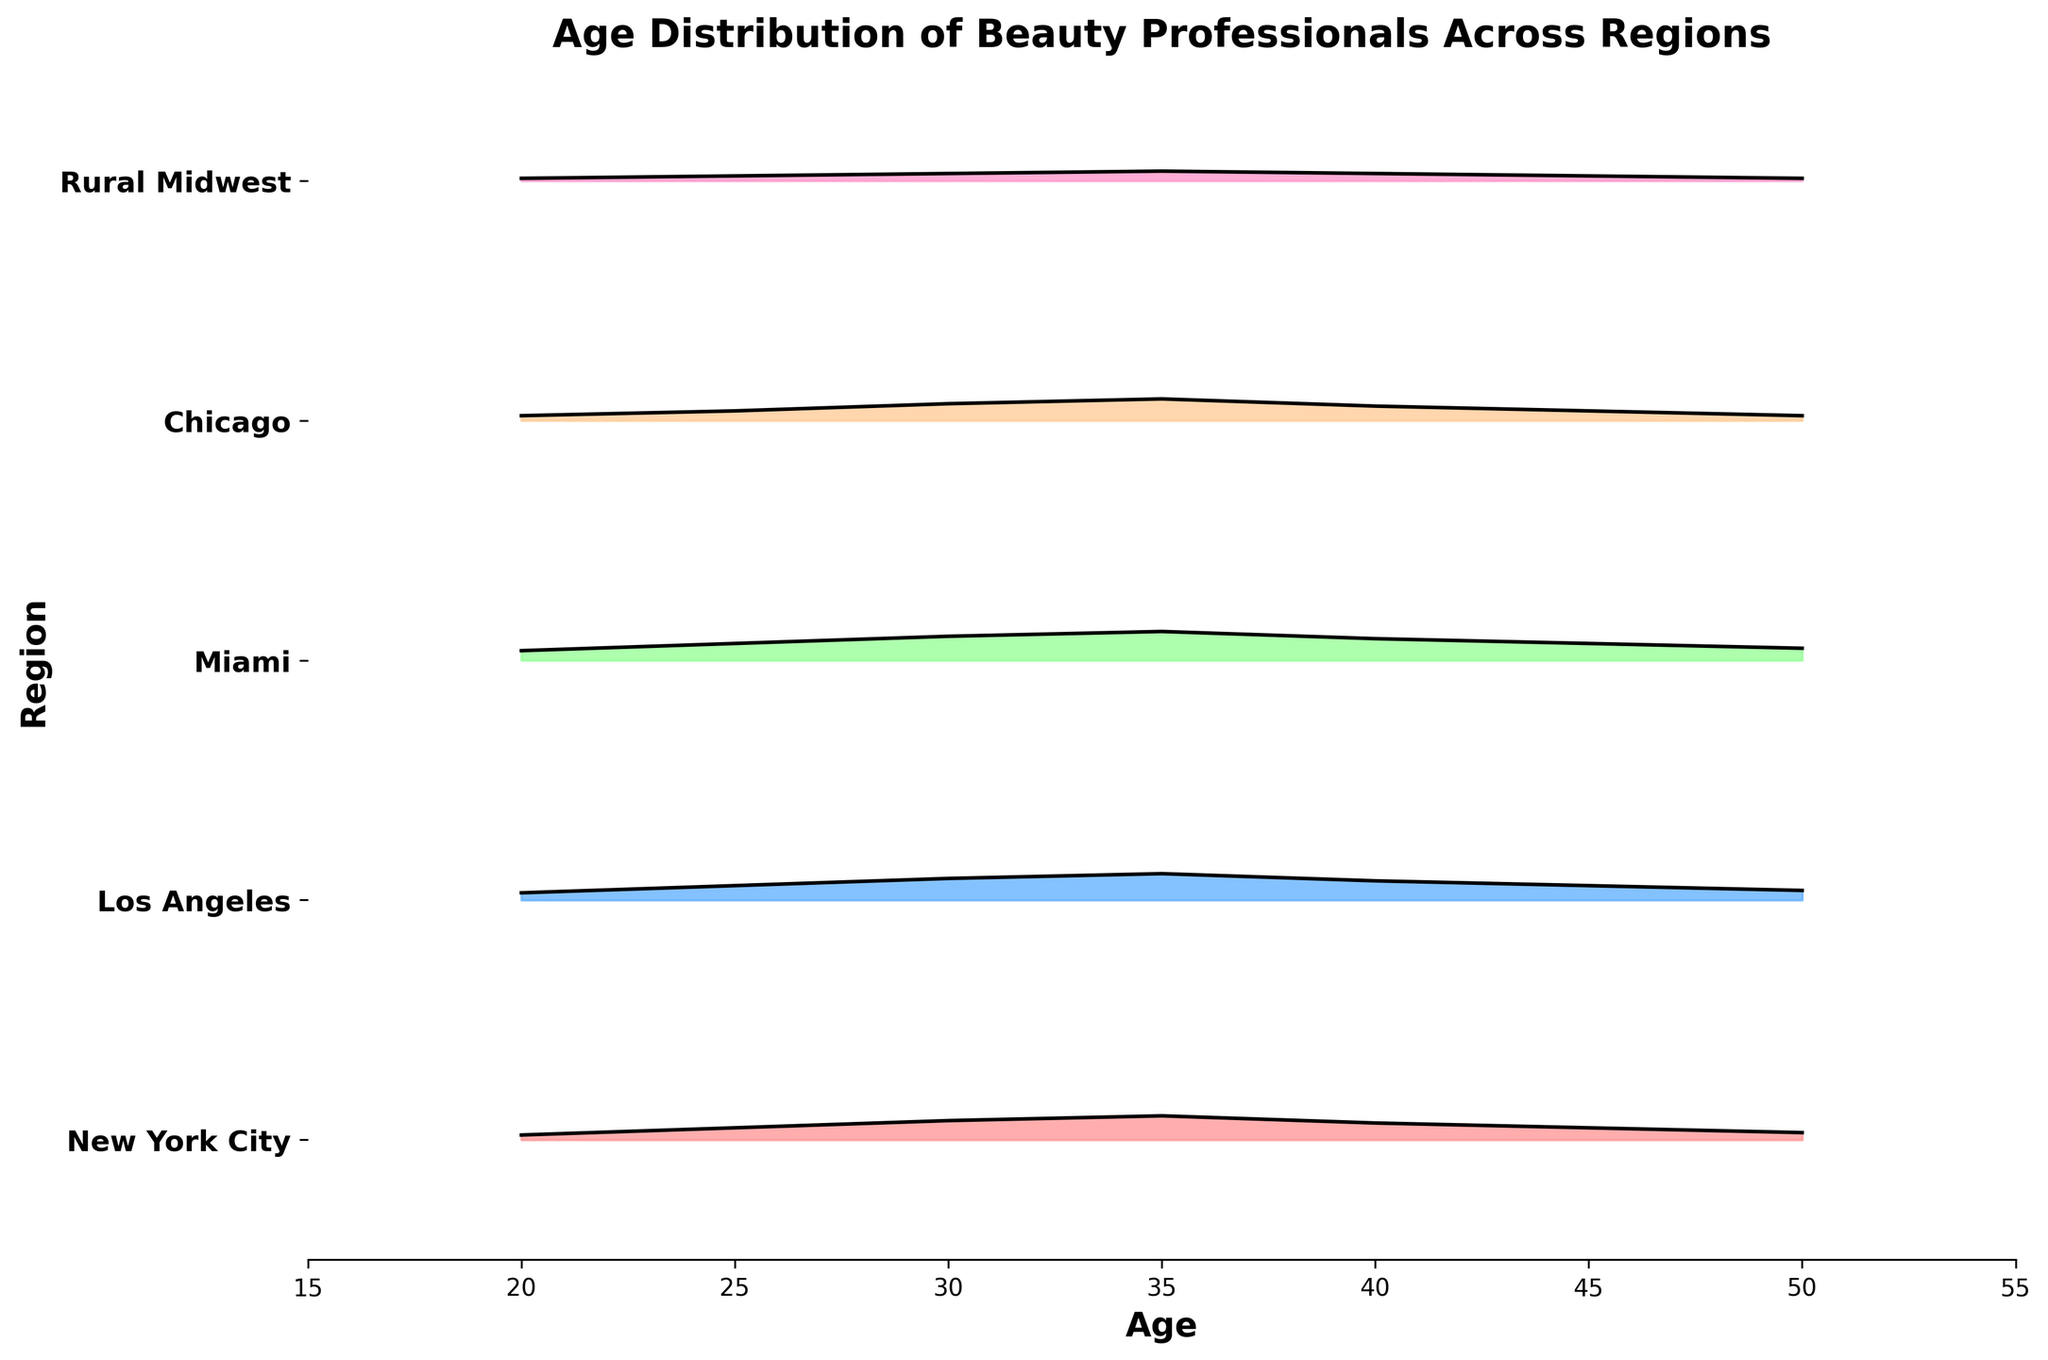Which region has the highest peak density for the age distribution of beauty professionals? By observing the Ridgeline plot, we look for the highest peak (density) among all regions. The region with the highest peak is Miami.
Answer: Miami Which age group is most common for beauty professionals in Chicago? In the Ridgeline plot, the highest peak for Chicago is at age 35, signifying the most common age group for beauty professionals in Chicago.
Answer: 35 What does the x-axis represent in the Ridgeline plot? The x-axis is labeled 'Age', signifying that it represents the ages of the beauty professionals in the plot.
Answer: Age How does the age distribution of beauty professionals in the Rural Midwest compare to that in Los Angeles? By comparing the density curves for Rural Midwest and Los Angeles, we see that Los Angeles has a broader age range, and higher peaks indicating a higher density of beauty professionals across more ages compared to the Rural Midwest.
Answer: Los Angeles has a broader and denser distribution Which region has the least density of beauty professionals aged 50? Observing the Ridgeline plot, the region with the smallest peak at age 50 is the Rural Midwest.
Answer: Rural Midwest What is the age range where Miami has consistently higher densities compared to New York City? By comparing the plots, Miami consistently shows higher densities than New York City from ages 25 to 45.
Answer: 25 to 45 Which region shows a sharp decline in the density of beauty professionals after age 40? By observing the trend in each region, it's clear that Chicago shows a sharp decline in density after age 40.
Answer: Chicago What is the title of the Ridgeline plot? The title of the Ridgeline plot is "Age Distribution of Beauty Professionals Across Regions".
Answer: Age Distribution of Beauty Professionals Across Regions How does the age distribution for beauty professionals in New York City differ from that in Miami at age 35? At age 35, Miami has a higher density of beauty professionals compared to New York City, indicating more beauty professionals in that age group in Miami.
Answer: Miami has a higher density Which age group is least common for beauty professionals across all regions? By observing the lowest peaks in every region, age 50 appears to have the least density in general across all regions.
Answer: 50 